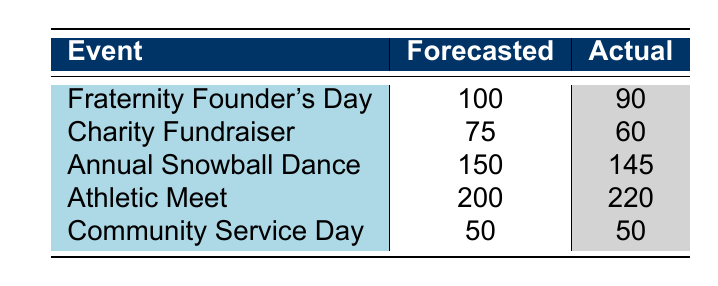What is the actual number of participants in the Charity Fundraiser? Referring to the table, the Charity Fundraiser shows an actual participant count of 60.
Answer: 60 How many more participants were forecasted for the Athletic Meet than the actual number? The forecasted participants for the Athletic Meet are 200, while the actual participants are 220. To find the difference, we subtract the actual number from the forecasted number: 200 - 220 = -20, indicating that the actual count exceeded the forecast.
Answer: -20 Did the Annual Snowball Dance meet its forecasted participation? The forecasted participation for the Annual Snowball Dance is 150, and the actual participation is 145. Since 145 is less than 150, the event did not meet its forecast.
Answer: No What was the total number of participants across all events? To find the total, we look at the actual participants from each event: 90 (Founder's Day) + 60 (Charity Fundraiser) + 145 (Snowball Dance) + 220 (Athletic Meet) + 50 (Community Service Day) = 665 participants total.
Answer: 665 Which event had the highest forecasted participants? By examining the forecasted numbers, the Athletic Meet had the highest forecasted number, which is 200.
Answer: Athletic Meet 